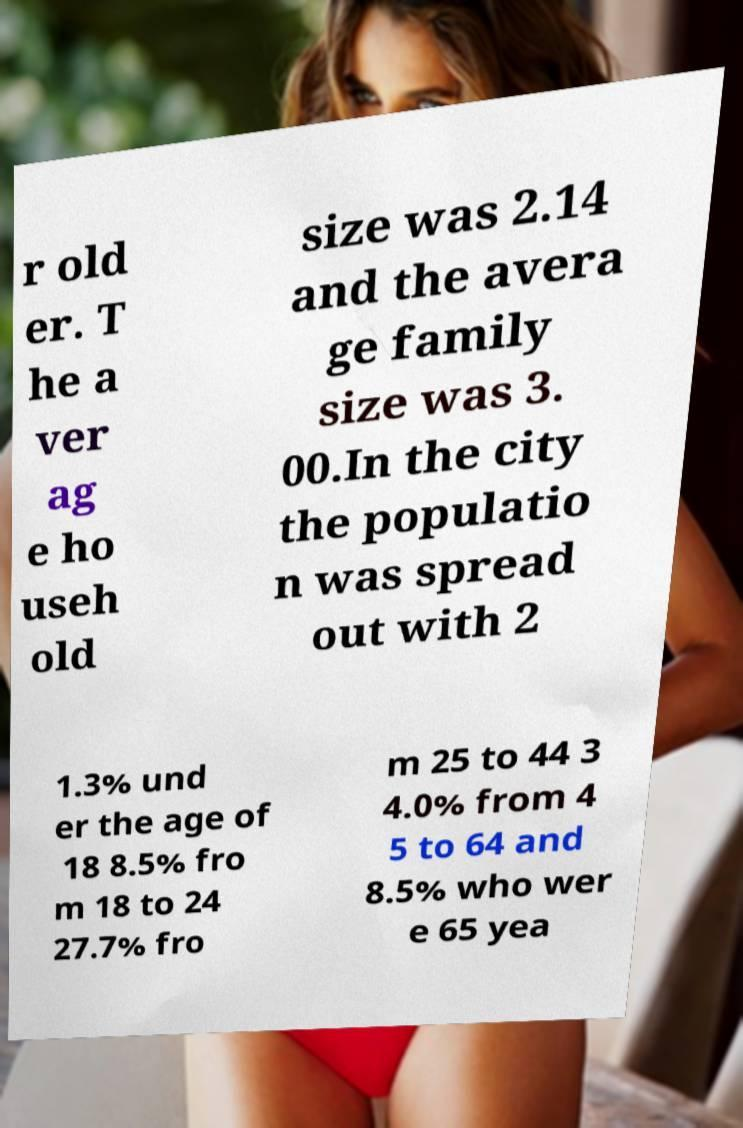For documentation purposes, I need the text within this image transcribed. Could you provide that? r old er. T he a ver ag e ho useh old size was 2.14 and the avera ge family size was 3. 00.In the city the populatio n was spread out with 2 1.3% und er the age of 18 8.5% fro m 18 to 24 27.7% fro m 25 to 44 3 4.0% from 4 5 to 64 and 8.5% who wer e 65 yea 